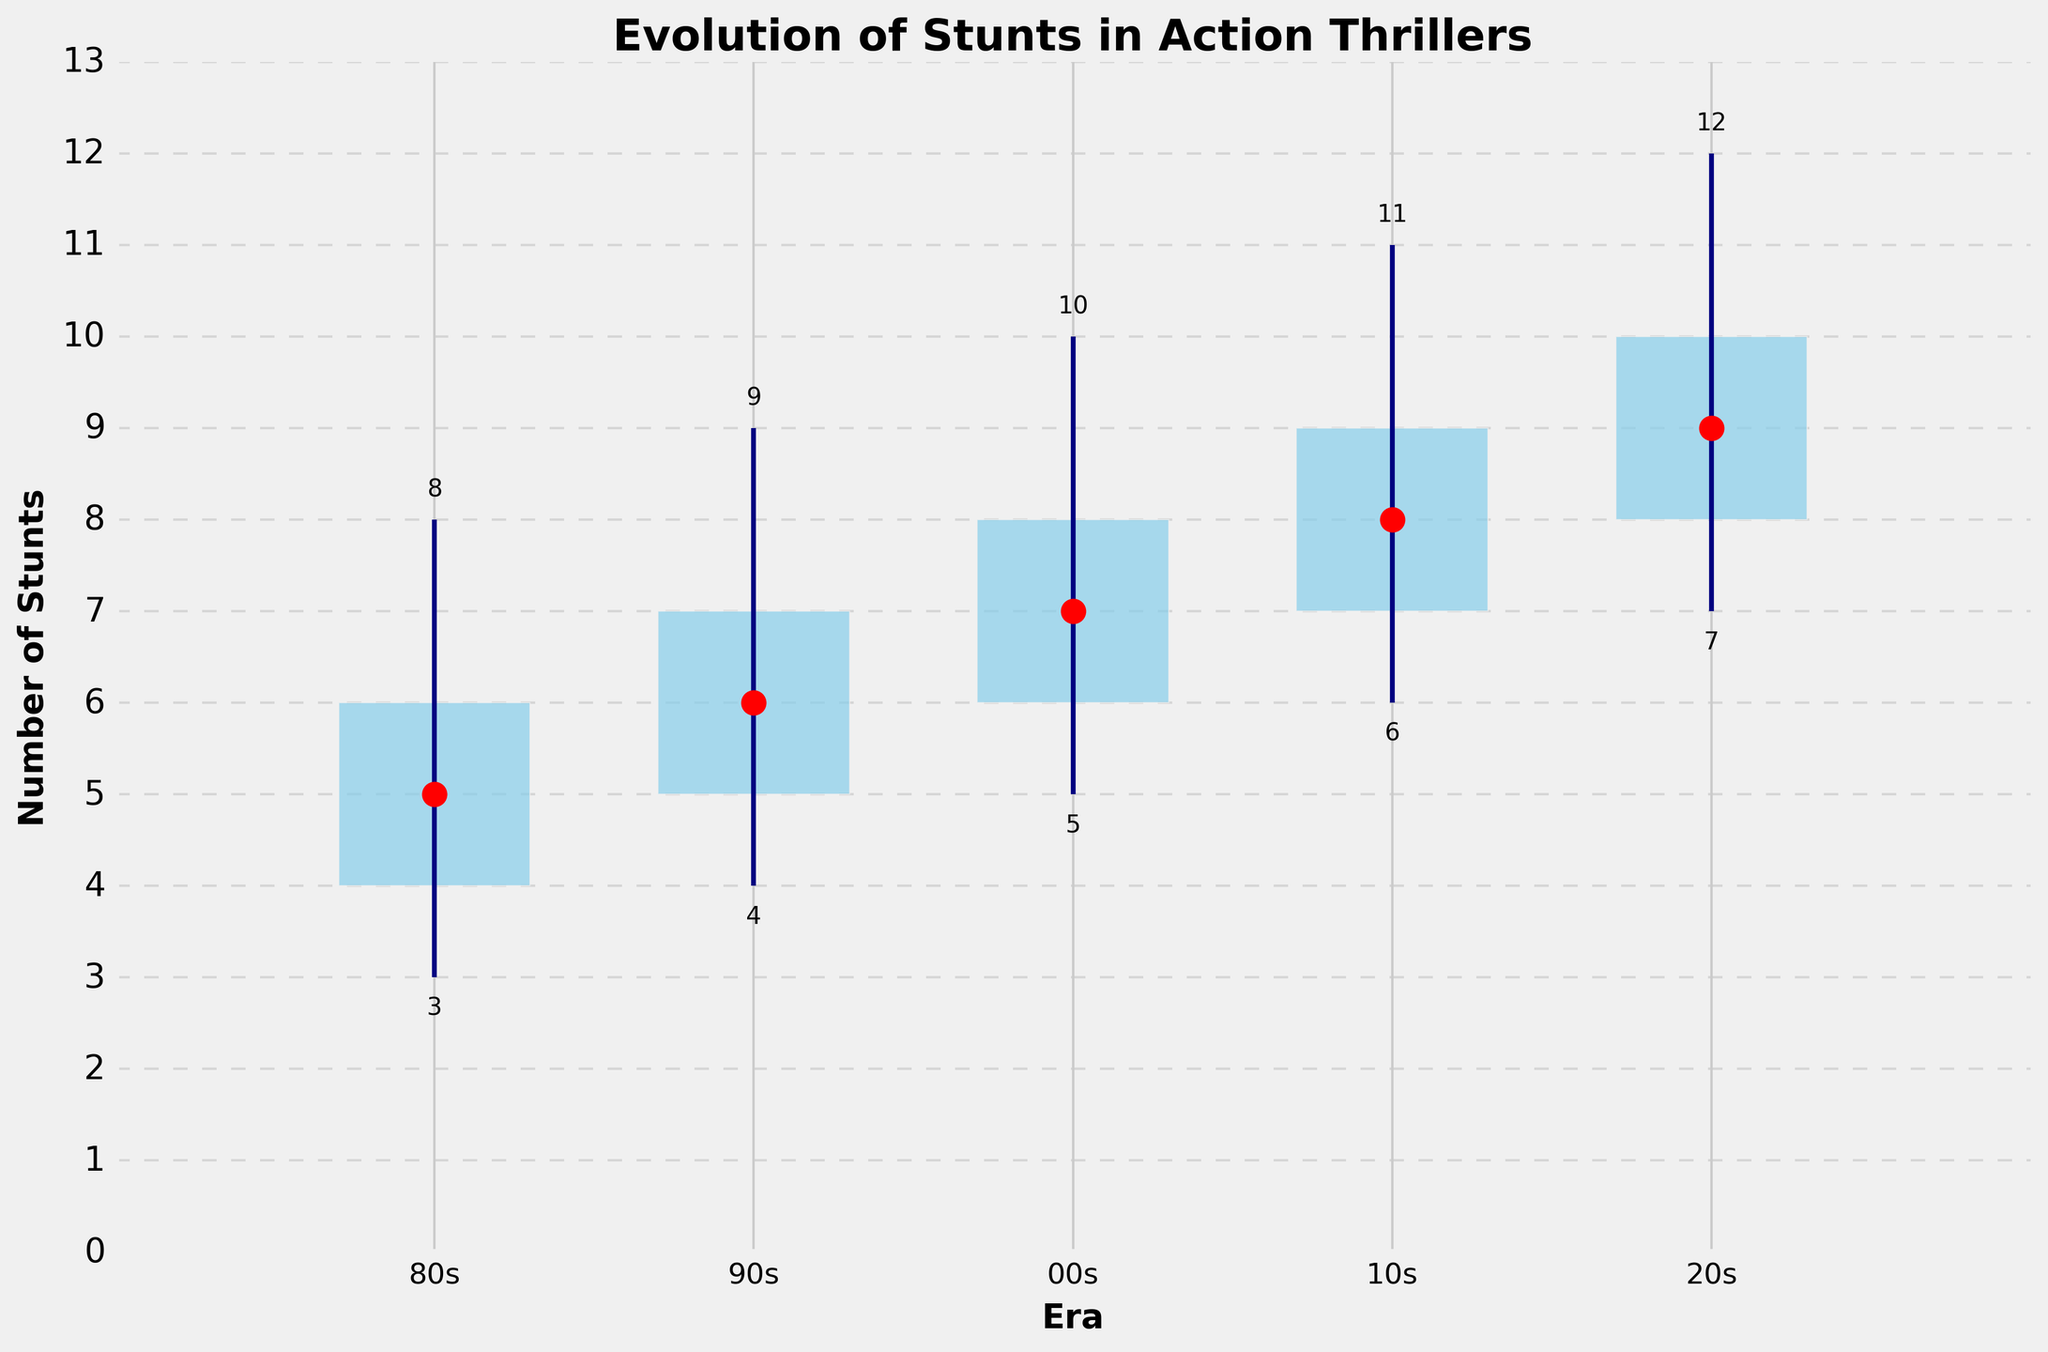What is the total number of eras represented in the plot? Count the number of distinct eras on the x-axis. There are five eras shown: 80s, 90s, 00s, 10s, and 20s.
Answer: Five What is the title of the plot? Read the text at the top of the plot. It is written as a title.
Answer: Evolution of Stunts in Action Thrillers How many stunts does the 2010s era have at maximum? Look at the maximum value indicated by the top end of the vertical line for the 2010s era.
Answer: 11 Which era has the minimum number of stunts? Check the lowest point of the vertical line for all eras and identify the earliest era with the lowest value.
Answer: 1980s What is the median number of stunts in the 2020s? Find the median value shown as a red dot in the 2020s era column.
Answer: 9 Which era has the largest interquartile range (difference between the first and third quartiles)? Calculate the difference (Third Quartile - First Quartile) for each era and compare.
Answer: All eras have the same range of 2 How does the minimum number of stunts in the 2020s compare to the maximum number of stunts in the 1980s? Compare the bottom of the vertical line in 2020s (7) with the top of the vertical line in 1980s (8). 7 is less than 8.
Answer: The minimum in the 2020s is less than the maximum in the 1980s What is the overall trend in the median number of stunts from the 1980s to the 2020s? Observe the pattern of the red dots (median) across all eras, noting the upward trend.
Answer: Increasing By how much has the median number of stunts increased from the 1980s to the 2020s? Subtract the median for the 1980s (5) from the median for the 2020s (9).
Answer: 4 What is the range of stunt numbers in the 1990s? Subtract the minimum number of stunts (4) from the maximum number of stunts (9) in the 1990s.
Answer: 5 